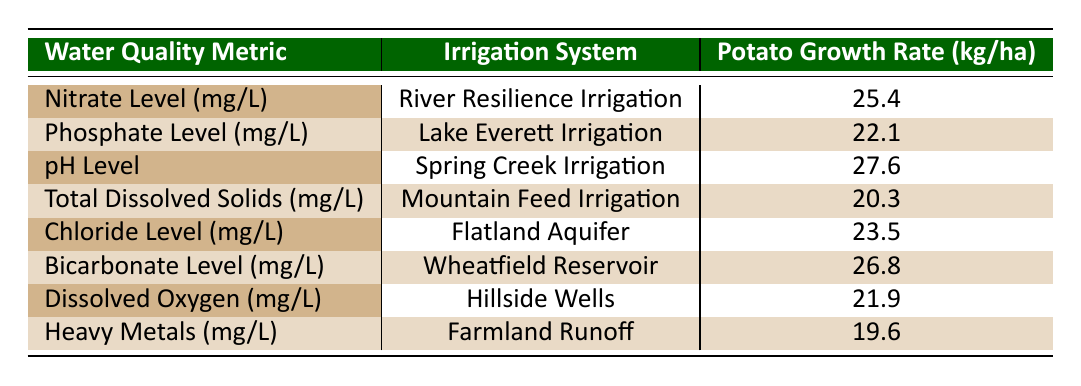What is the potato growth rate for the Spring Creek Irrigation system? The table shows that for the Spring Creek Irrigation system, the potato growth rate is listed directly as 27.6 kg/ha.
Answer: 27.6 kg/ha Which irrigation system has the lowest potato growth rate? By comparing the potato growth rates from each row, Mountain Feed Irrigation has the lowest growth rate at 20.3 kg/ha.
Answer: Mountain Feed Irrigation What is the average potato growth rate across all irrigation systems listed? To find the average, sum the values (25.4 + 22.1 + 27.6 + 20.3 + 23.5 + 26.8 + 21.9 + 19.6 = 190.2 kg/ha) and divide by the number of systems (8), resulting in an average of 190.2/8 = 23.775 kg/ha.
Answer: 23.775 kg/ha Is the Chloride Level associated with a higher or lower growth rate compared to the Heavy Metals level? From the table, the Chloride Level is associated with a potato growth rate of 23.5 kg/ha, while Heavy Metals is associated with 19.6 kg/ha. Therefore, Chloride Level is associated with a higher growth rate than Heavy Metals.
Answer: Higher What is the relationship between pH Level and potato growth rates compared to Total Dissolved Solids? The pH Level shows a growth rate of 27.6 kg/ha, which is higher than the Total Dissolved Solids growth rate of 20.3 kg/ha. This suggests that potato growth is better associated with pH Level compared to Total Dissolved Solids in the context of the data provided.
Answer: pH Level is better associated with growth 